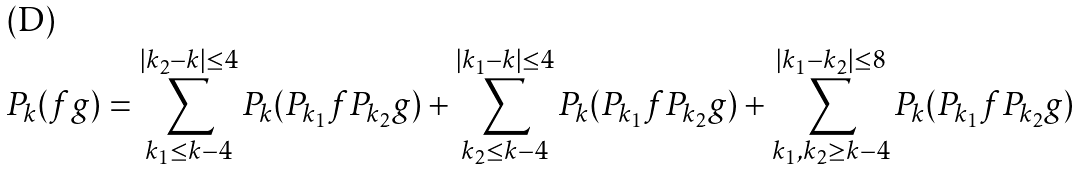Convert formula to latex. <formula><loc_0><loc_0><loc_500><loc_500>P _ { k } ( f g ) = \sum _ { k _ { 1 } \leq k - 4 } ^ { | k _ { 2 } - k | \leq 4 } P _ { k } ( P _ { k _ { 1 } } f P _ { k _ { 2 } } g ) + \sum _ { k _ { 2 } \leq k - 4 } ^ { | k _ { 1 } - k | \leq 4 } P _ { k } ( P _ { k _ { 1 } } f P _ { k _ { 2 } } g ) + \sum _ { k _ { 1 } , k _ { 2 } \geq k - 4 } ^ { | k _ { 1 } - k _ { 2 } | \leq 8 } P _ { k } ( P _ { k _ { 1 } } f P _ { k _ { 2 } } g )</formula> 